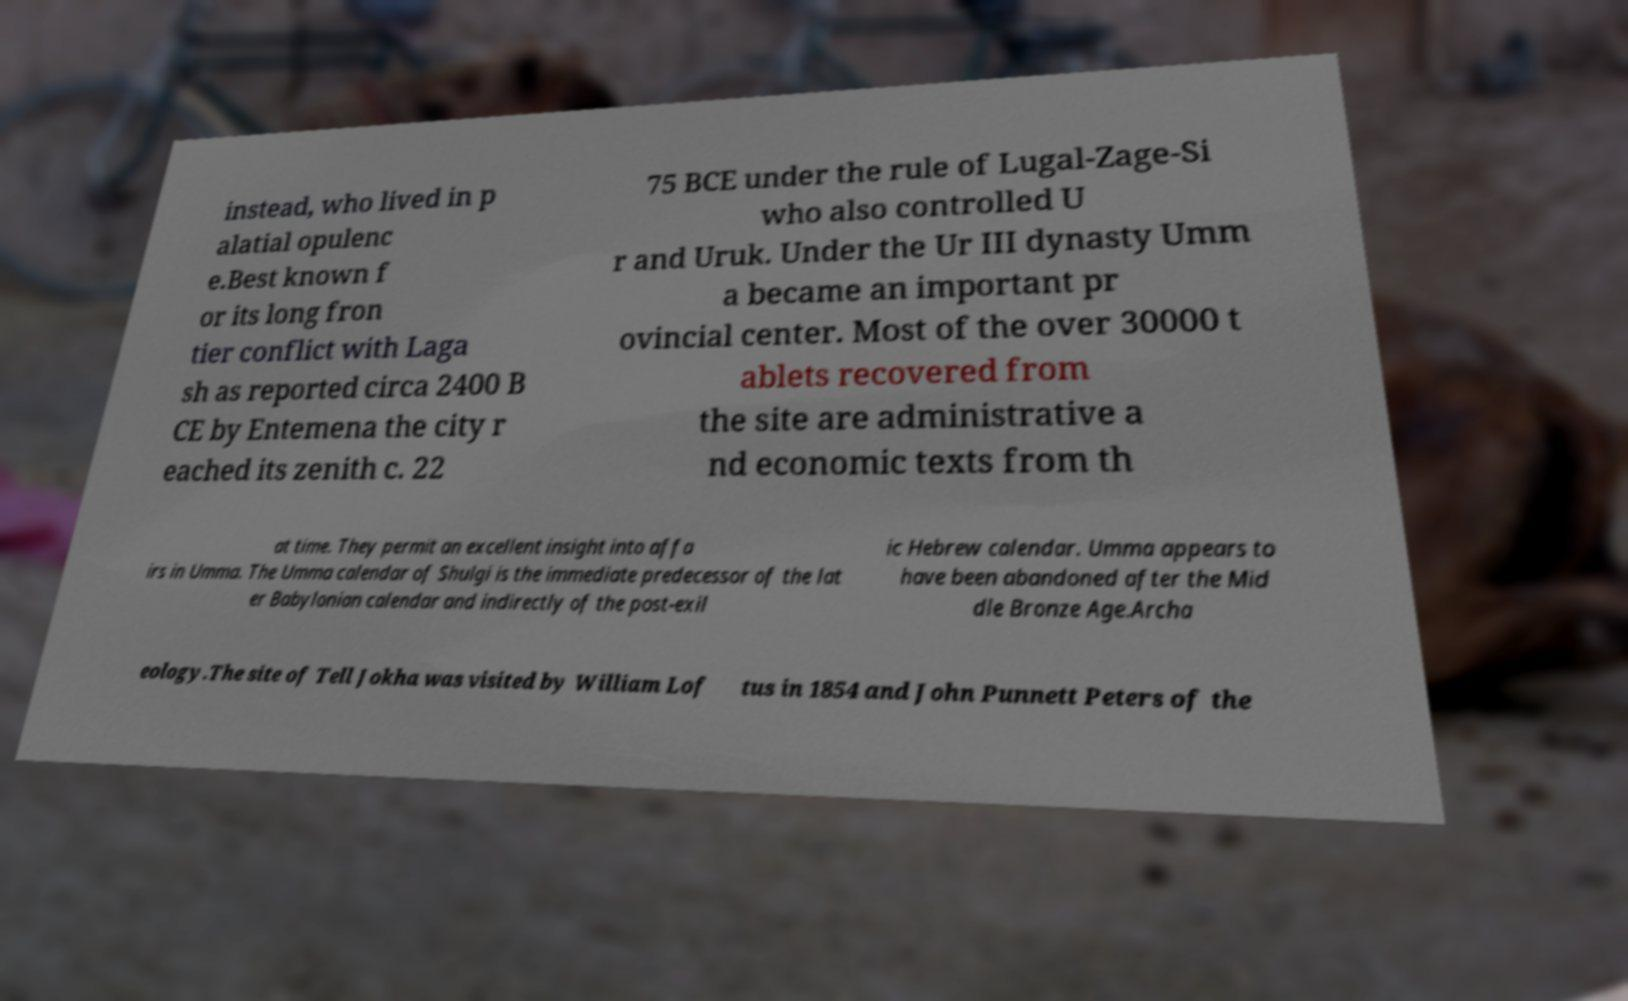Can you accurately transcribe the text from the provided image for me? instead, who lived in p alatial opulenc e.Best known f or its long fron tier conflict with Laga sh as reported circa 2400 B CE by Entemena the city r eached its zenith c. 22 75 BCE under the rule of Lugal-Zage-Si who also controlled U r and Uruk. Under the Ur III dynasty Umm a became an important pr ovincial center. Most of the over 30000 t ablets recovered from the site are administrative a nd economic texts from th at time. They permit an excellent insight into affa irs in Umma. The Umma calendar of Shulgi is the immediate predecessor of the lat er Babylonian calendar and indirectly of the post-exil ic Hebrew calendar. Umma appears to have been abandoned after the Mid dle Bronze Age.Archa eology.The site of Tell Jokha was visited by William Lof tus in 1854 and John Punnett Peters of the 